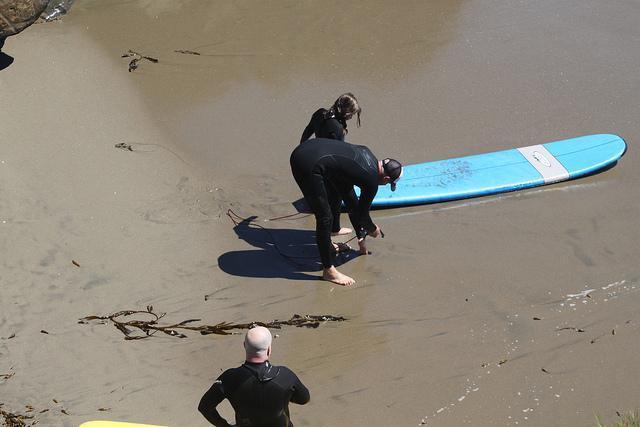How many people can be seen?
Give a very brief answer. 3. 